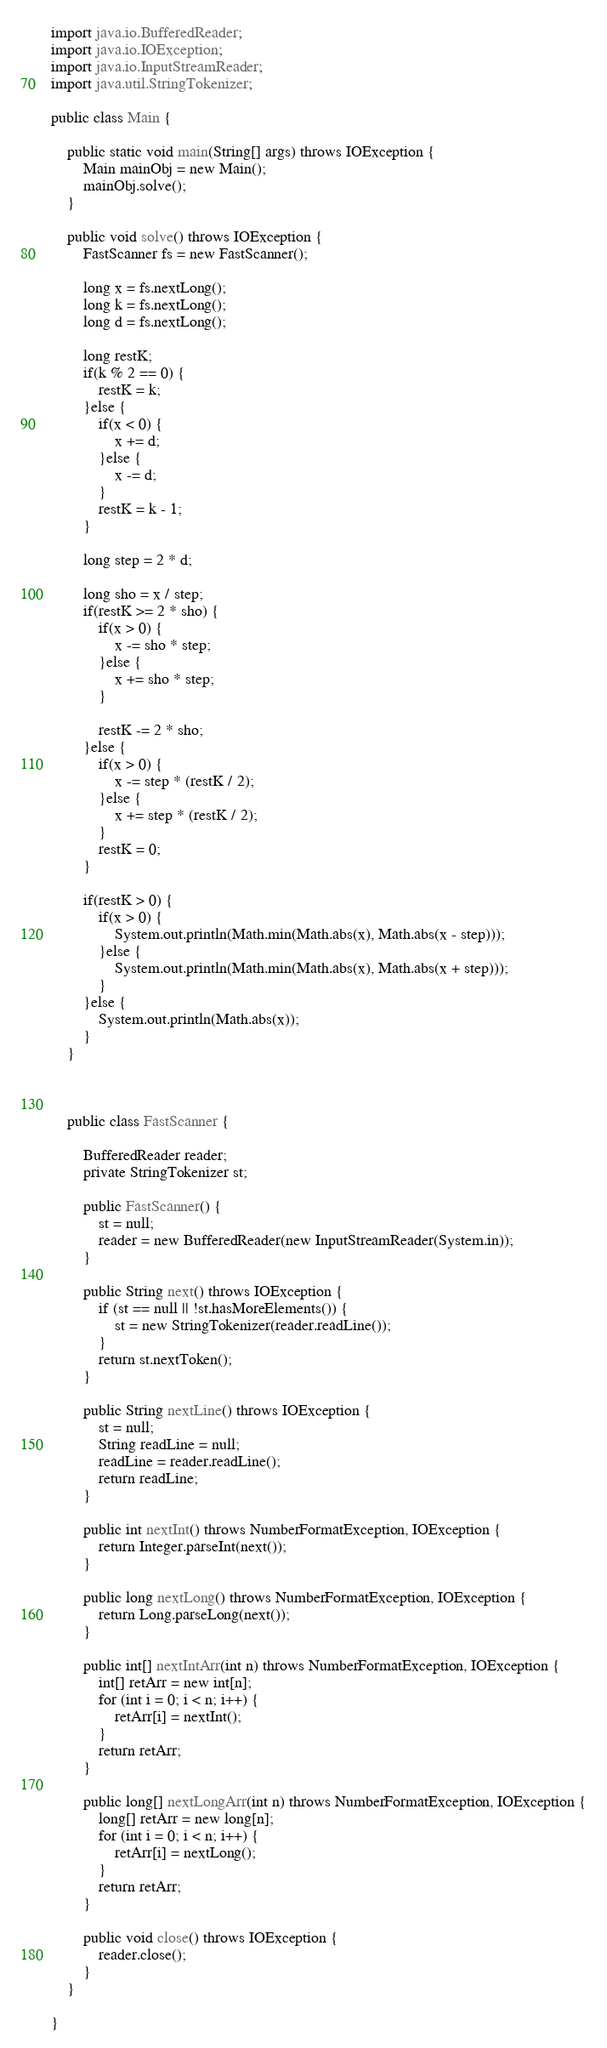<code> <loc_0><loc_0><loc_500><loc_500><_Java_>import java.io.BufferedReader;
import java.io.IOException;
import java.io.InputStreamReader;
import java.util.StringTokenizer;

public class Main {

	public static void main(String[] args) throws IOException {
		Main mainObj = new Main();
		mainObj.solve();
	}

	public void solve() throws IOException {
		FastScanner fs = new FastScanner();
		
		long x = fs.nextLong();
		long k = fs.nextLong();
		long d = fs.nextLong();
		
		long restK;
		if(k % 2 == 0) {
			restK = k;
		}else {
			if(x < 0) {
				x += d;
			}else {
				x -= d;
			}
			restK = k - 1;
		}
		
		long step = 2 * d;
		
		long sho = x / step;
		if(restK >= 2 * sho) {
			if(x > 0) {
				x -= sho * step;
			}else {
				x += sho * step;
			}
			
			restK -= 2 * sho;
		}else {
			if(x > 0) {
				x -= step * (restK / 2);
			}else {
				x += step * (restK / 2);
			}
			restK = 0;
		}
		
		if(restK > 0) {
			if(x > 0) {
				System.out.println(Math.min(Math.abs(x), Math.abs(x - step)));
			}else {
				System.out.println(Math.min(Math.abs(x), Math.abs(x + step)));
			}
		}else {
			System.out.println(Math.abs(x));
		}
	}

	

	public class FastScanner {

		BufferedReader reader;
		private StringTokenizer st;

		public FastScanner() {
			st = null;
			reader = new BufferedReader(new InputStreamReader(System.in));
		}

		public String next() throws IOException {
			if (st == null || !st.hasMoreElements()) {
				st = new StringTokenizer(reader.readLine());
			}
			return st.nextToken();
		}

		public String nextLine() throws IOException {
			st = null;
			String readLine = null;
			readLine = reader.readLine();
			return readLine;
		}

		public int nextInt() throws NumberFormatException, IOException {
			return Integer.parseInt(next());
		}

		public long nextLong() throws NumberFormatException, IOException {
			return Long.parseLong(next());
		}

		public int[] nextIntArr(int n) throws NumberFormatException, IOException {
			int[] retArr = new int[n];
			for (int i = 0; i < n; i++) {
				retArr[i] = nextInt();
			}
			return retArr;
		}

		public long[] nextLongArr(int n) throws NumberFormatException, IOException {
			long[] retArr = new long[n];
			for (int i = 0; i < n; i++) {
				retArr[i] = nextLong();
			}
			return retArr;
		}

		public void close() throws IOException {
			reader.close();
		}
	}

}
</code> 